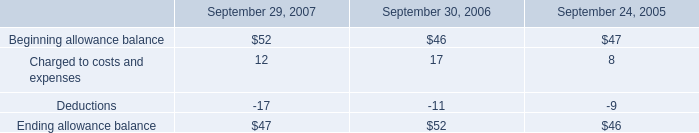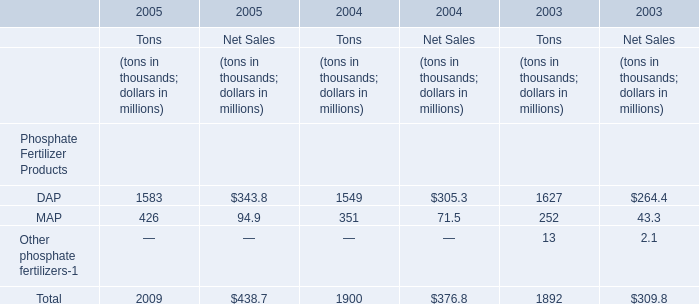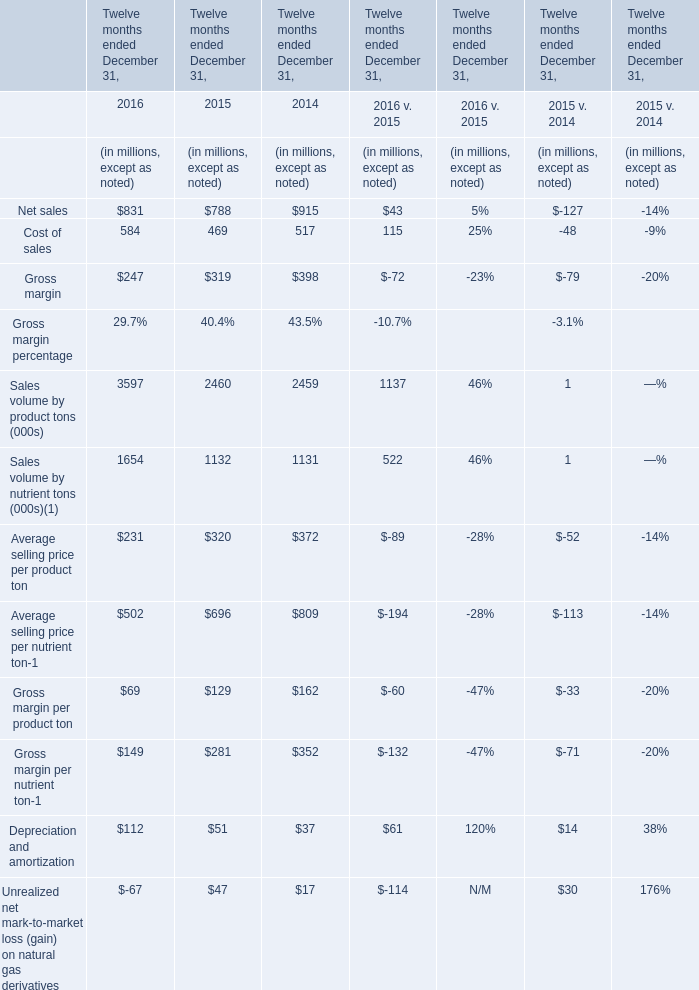what was the percentage change in the allowance for doubtful accounts from 2005 to 2006? 
Computations: ((52 - 46) / 46)
Answer: 0.13043. 